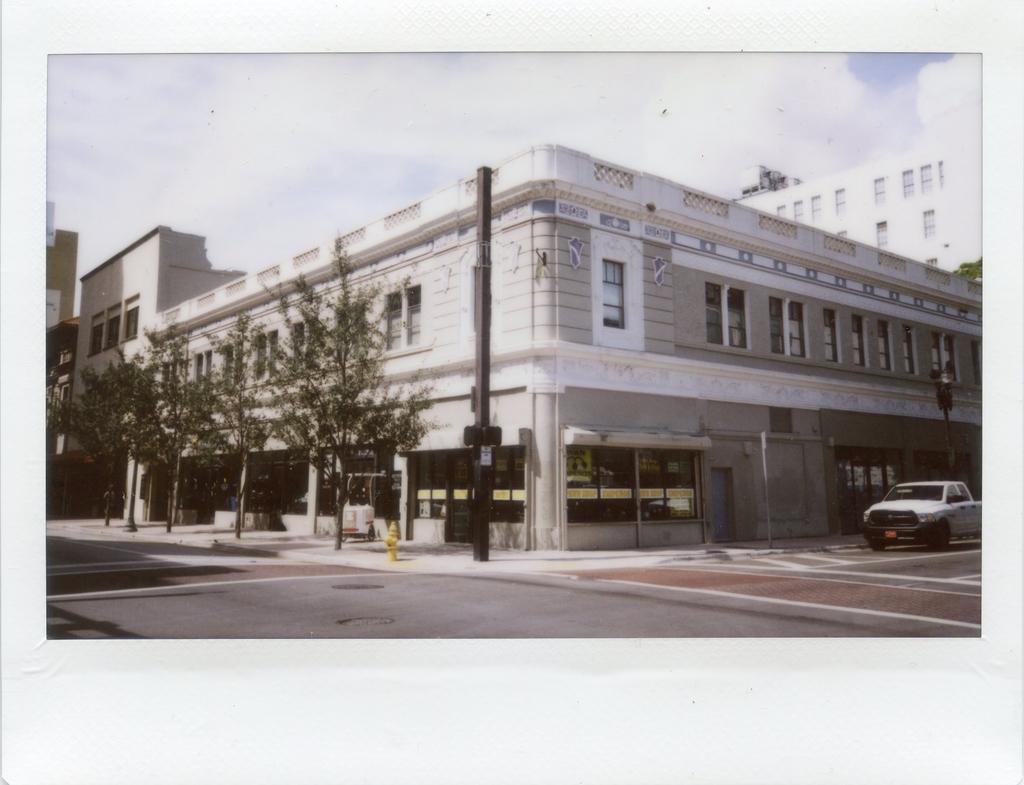Please provide a concise description of this image. In this image we can see some buildings with windows. We can also see some trees, poles and a car on the road. On the backside we can see the sky which looks cloudy. 